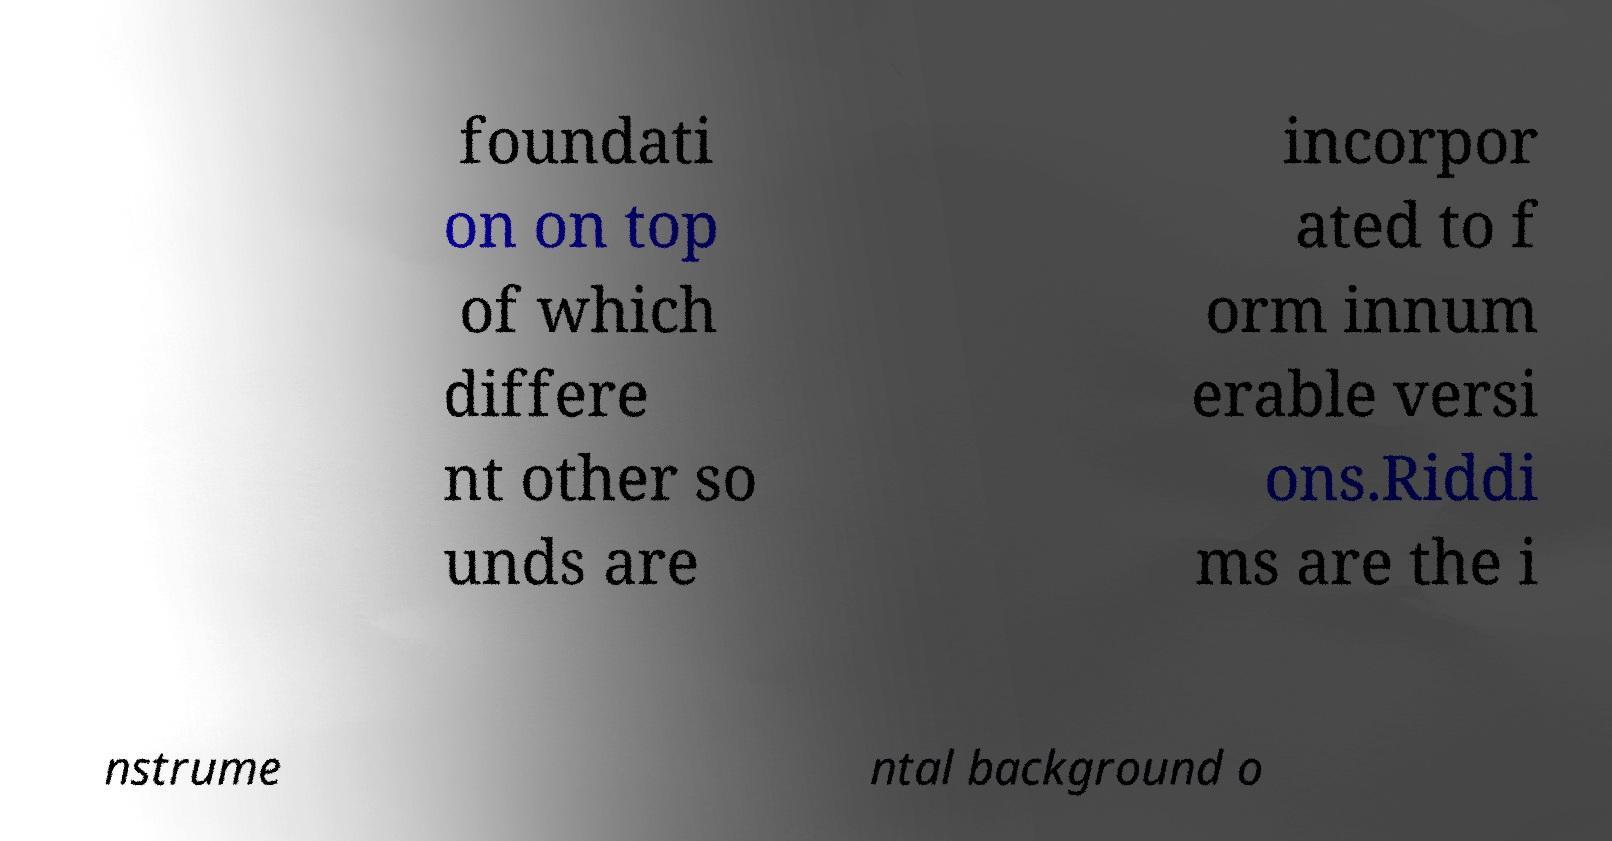For documentation purposes, I need the text within this image transcribed. Could you provide that? foundati on on top of which differe nt other so unds are incorpor ated to f orm innum erable versi ons.Riddi ms are the i nstrume ntal background o 